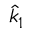Convert formula to latex. <formula><loc_0><loc_0><loc_500><loc_500>\hat { k } _ { 1 }</formula> 